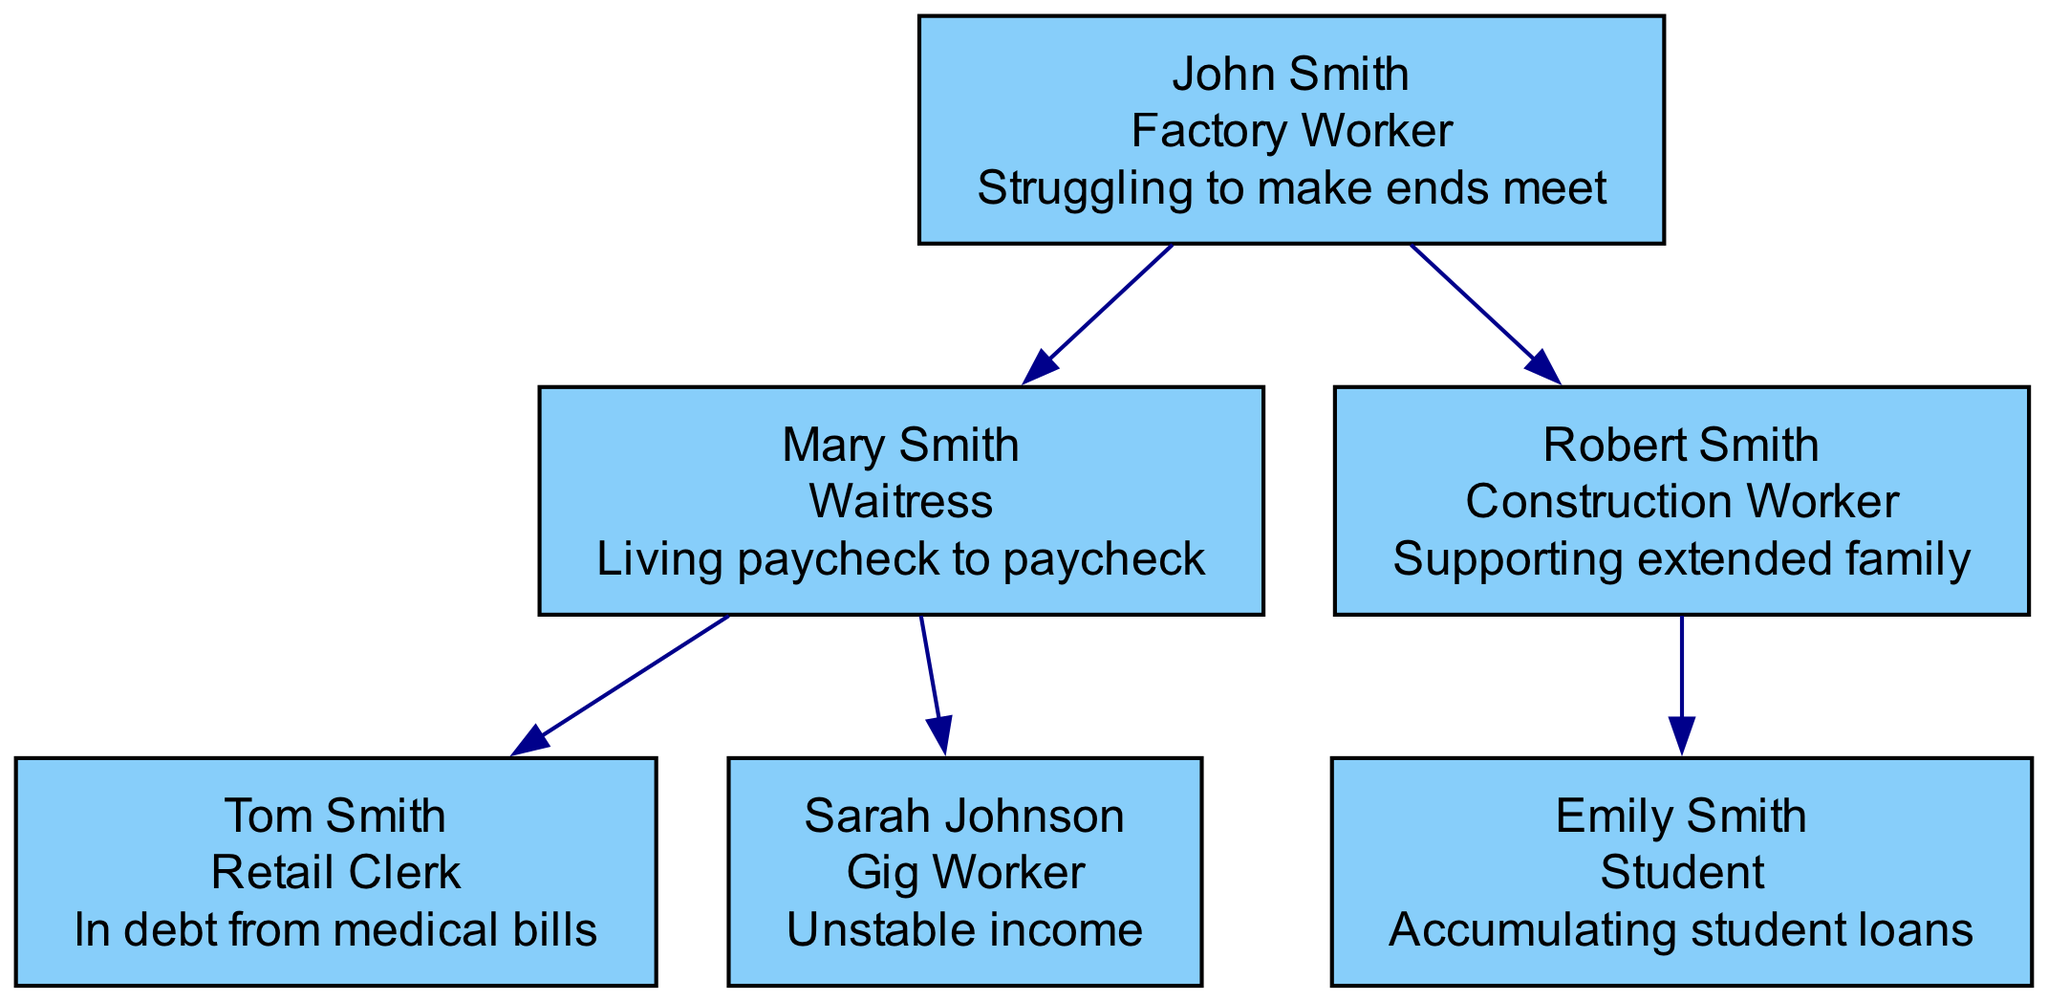What is John's occupation? The diagram shows that John Smith's occupation is specified directly in the root node, which indicates he is a Factory Worker.
Answer: Factory Worker How many children does Mary Smith have? In the diagram, we can see two children listed under Mary Smith: Tom Smith and Sarah Johnson. Therefore, the count of her children is 2.
Answer: 2 What is the financial status of Robert Smith? By looking at Robert Smith's node in the diagram, it states that his financial status is "Supporting extended family," providing the necessary answer directly.
Answer: Supporting extended family Which family member is a Gig Worker? The diagram points out that under Mary Smith, one of the children is Sarah Johnson, whose occupation is labeled as a Gig Worker.
Answer: Sarah Johnson How many generations are represented in this family tree? The diagram includes John Smith as the root of the first generation, Mary Smith and Robert Smith as the second generation, and their respective children, making three generations in total.
Answer: 3 Which member has debt from medical bills? Upon examining the diagram, it is clear that Tom Smith's financial status indicates he is "In debt from medical bills," answering the question directly.
Answer: Tom Smith What is Emily Smith's financial status? Going to Emily Smith's node, it clarifies that her financial status is "Accumulating student loans," which provides a clear answer.
Answer: Accumulating student loans Who is the child of Robert Smith? By analyzing Robert Smith's node, it lists Emily Smith as his child explicitly, giving the answer directly.
Answer: Emily Smith How many people are listed in the family tree? By counting the nodes visible in the diagram, we see John Smith, Mary Smith, Robert Smith, Tom Smith, Sarah Johnson, and Emily Smith, totaling 6 people in the family tree.
Answer: 6 